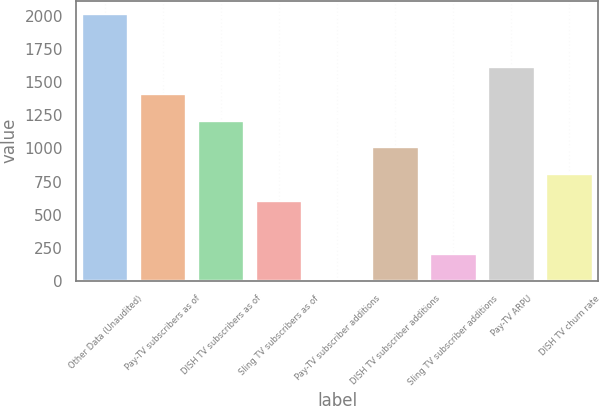Convert chart to OTSL. <chart><loc_0><loc_0><loc_500><loc_500><bar_chart><fcel>Other Data (Unaudited)<fcel>Pay-TV subscribers as of<fcel>DISH TV subscribers as of<fcel>Sling TV subscribers as of<fcel>Pay-TV subscriber additions<fcel>DISH TV subscriber additions<fcel>Sling TV subscriber additions<fcel>Pay-TV ARPU<fcel>DISH TV churn rate<nl><fcel>2015<fcel>1410.51<fcel>1209.02<fcel>604.55<fcel>0.08<fcel>1007.53<fcel>201.57<fcel>1612<fcel>806.04<nl></chart> 